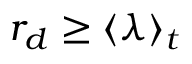Convert formula to latex. <formula><loc_0><loc_0><loc_500><loc_500>r _ { d } \geq \langle \lambda \rangle _ { t }</formula> 